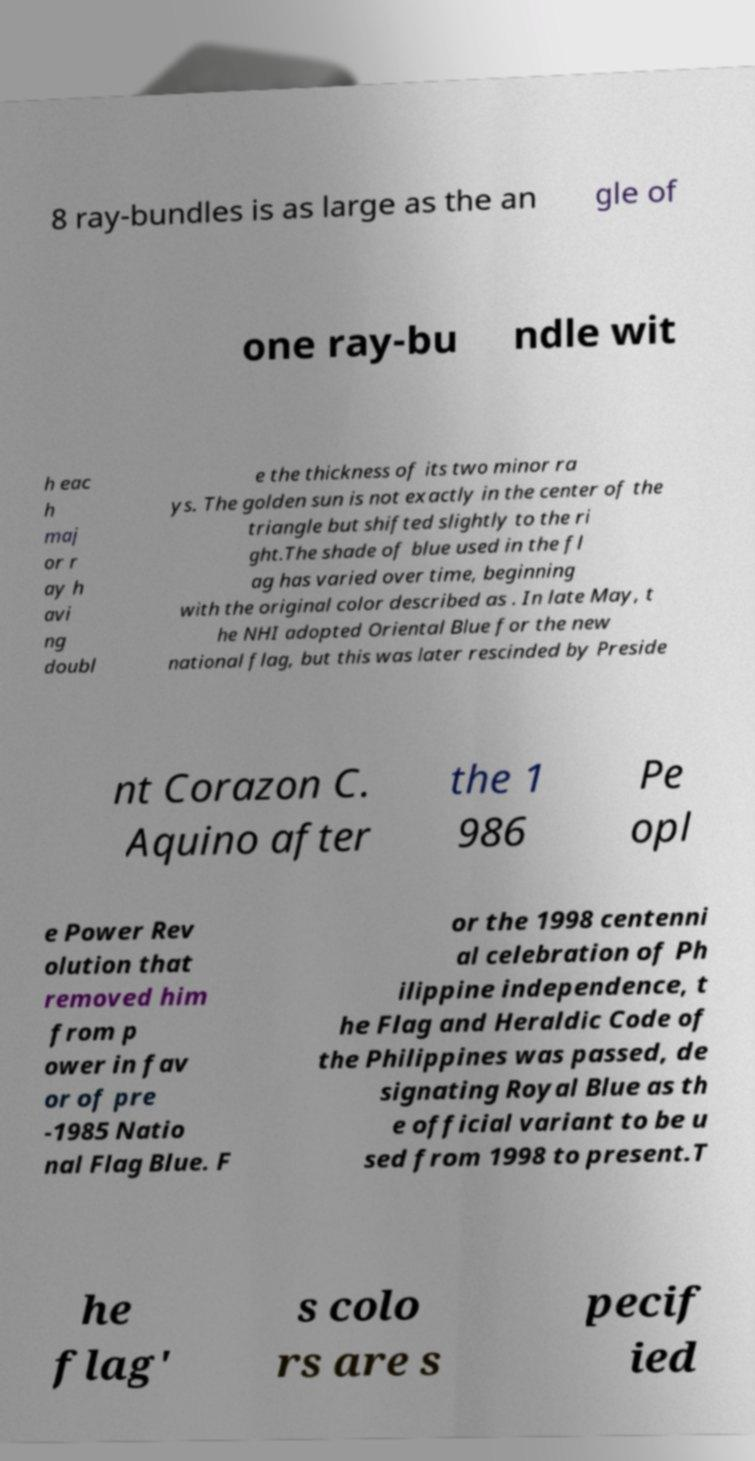There's text embedded in this image that I need extracted. Can you transcribe it verbatim? 8 ray-bundles is as large as the an gle of one ray-bu ndle wit h eac h maj or r ay h avi ng doubl e the thickness of its two minor ra ys. The golden sun is not exactly in the center of the triangle but shifted slightly to the ri ght.The shade of blue used in the fl ag has varied over time, beginning with the original color described as . In late May, t he NHI adopted Oriental Blue for the new national flag, but this was later rescinded by Preside nt Corazon C. Aquino after the 1 986 Pe opl e Power Rev olution that removed him from p ower in fav or of pre -1985 Natio nal Flag Blue. F or the 1998 centenni al celebration of Ph ilippine independence, t he Flag and Heraldic Code of the Philippines was passed, de signating Royal Blue as th e official variant to be u sed from 1998 to present.T he flag' s colo rs are s pecif ied 